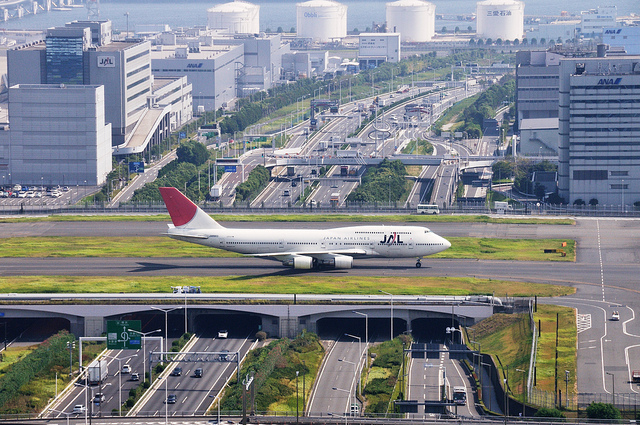Identify the text displayed in this image. JAL 